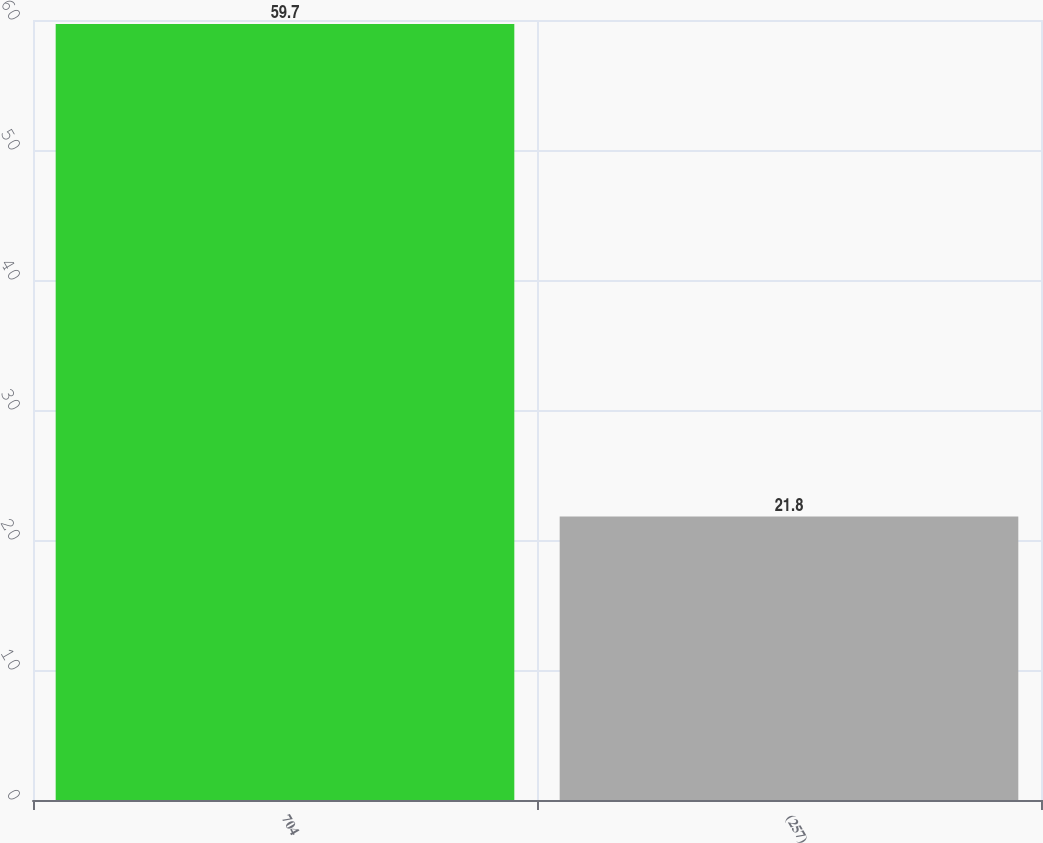Convert chart to OTSL. <chart><loc_0><loc_0><loc_500><loc_500><bar_chart><fcel>704<fcel>(257)<nl><fcel>59.7<fcel>21.8<nl></chart> 